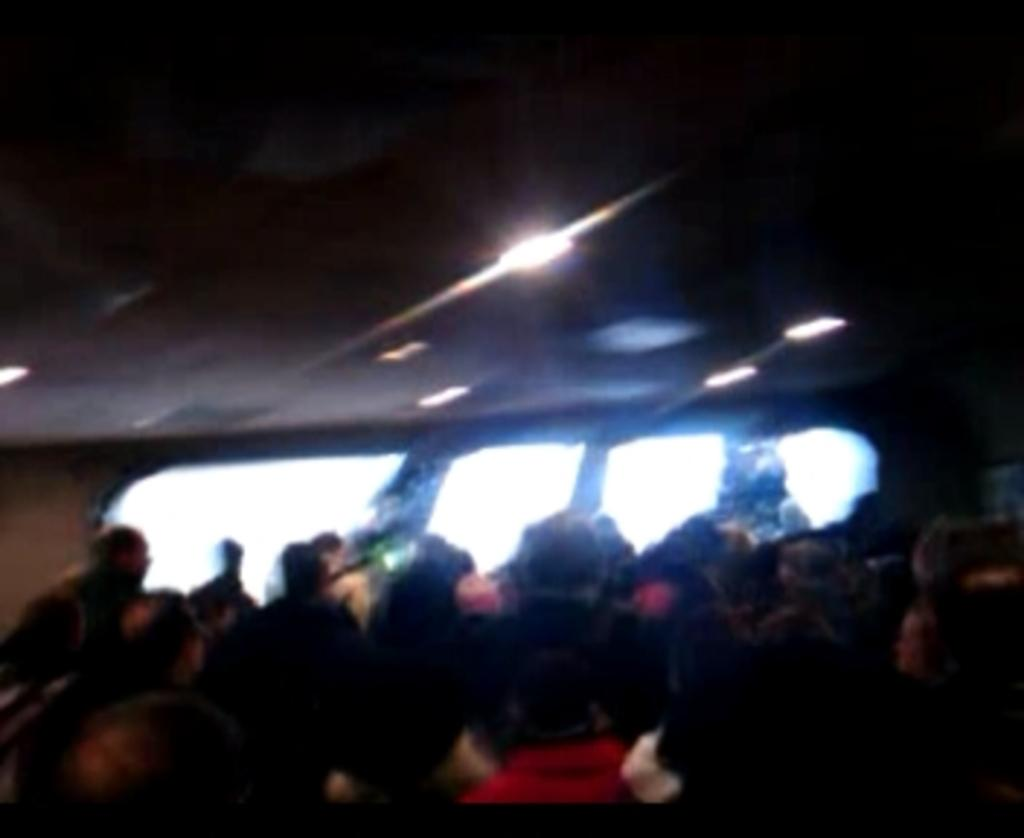What is the main subject of the image? The main subject of the image is a group of people. What architectural features can be seen in the image? Windows are visible in the image. What type of illumination is present in the image? Lights are visible in the image. Can you tell me how deep the lake is in the image? There is no lake present in the image; it features a group of people, windows, and lights. What type of camp can be seen in the image? There is no camp present in the image. 